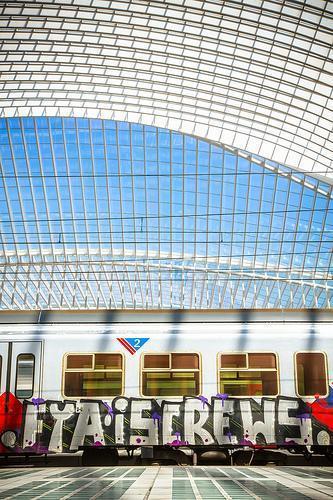How many train windows are pictured?
Give a very brief answer. 5. 